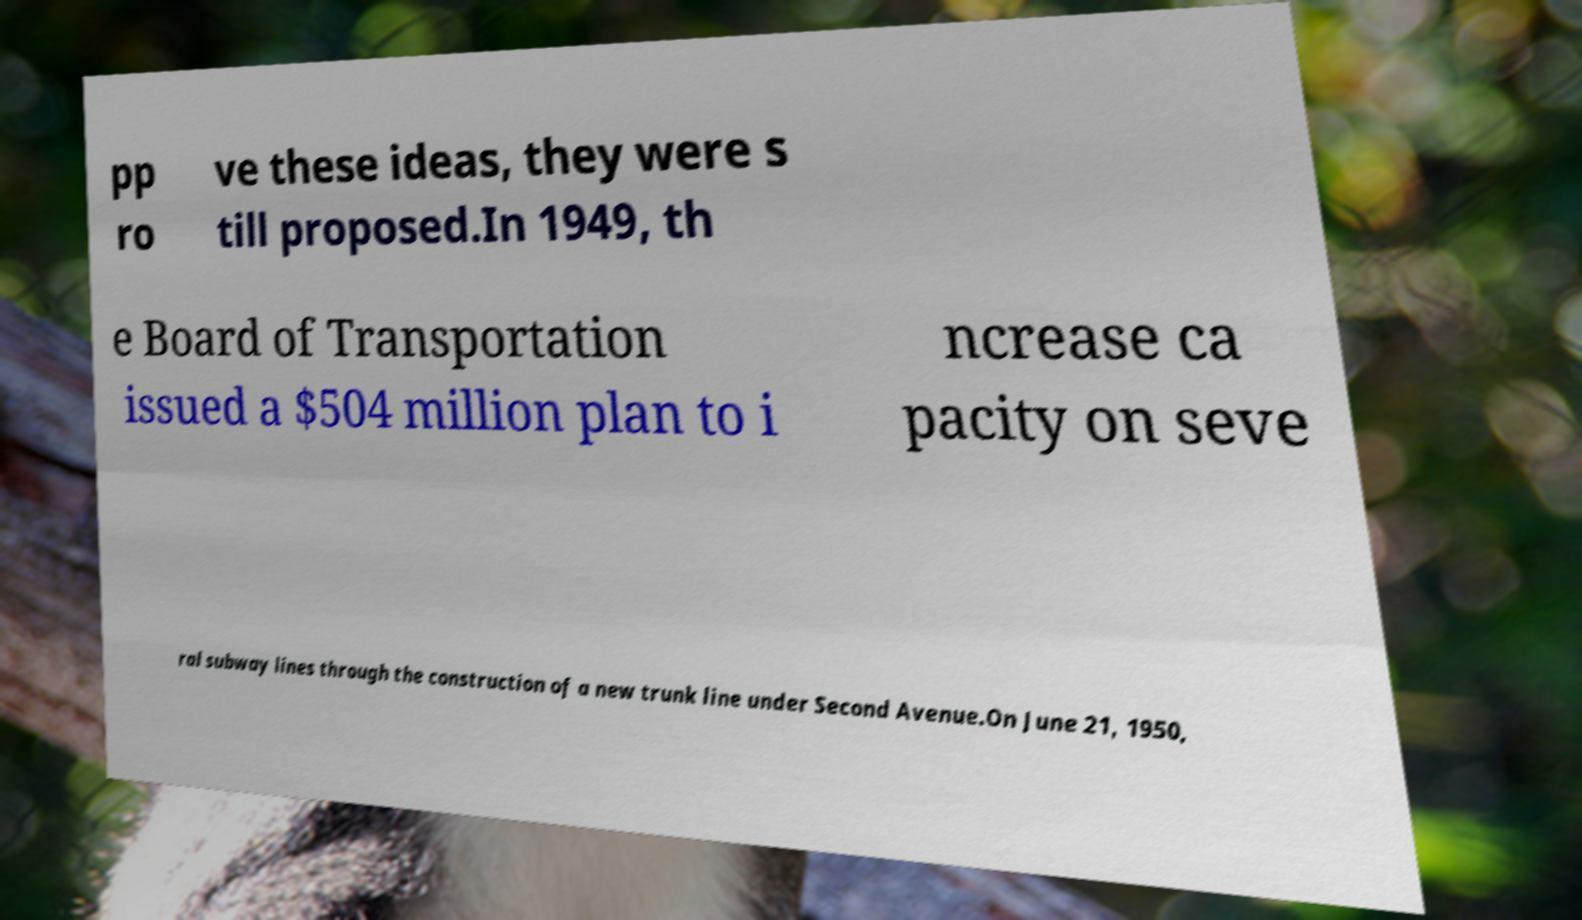Please read and relay the text visible in this image. What does it say? pp ro ve these ideas, they were s till proposed.In 1949, th e Board of Transportation issued a $504 million plan to i ncrease ca pacity on seve ral subway lines through the construction of a new trunk line under Second Avenue.On June 21, 1950, 